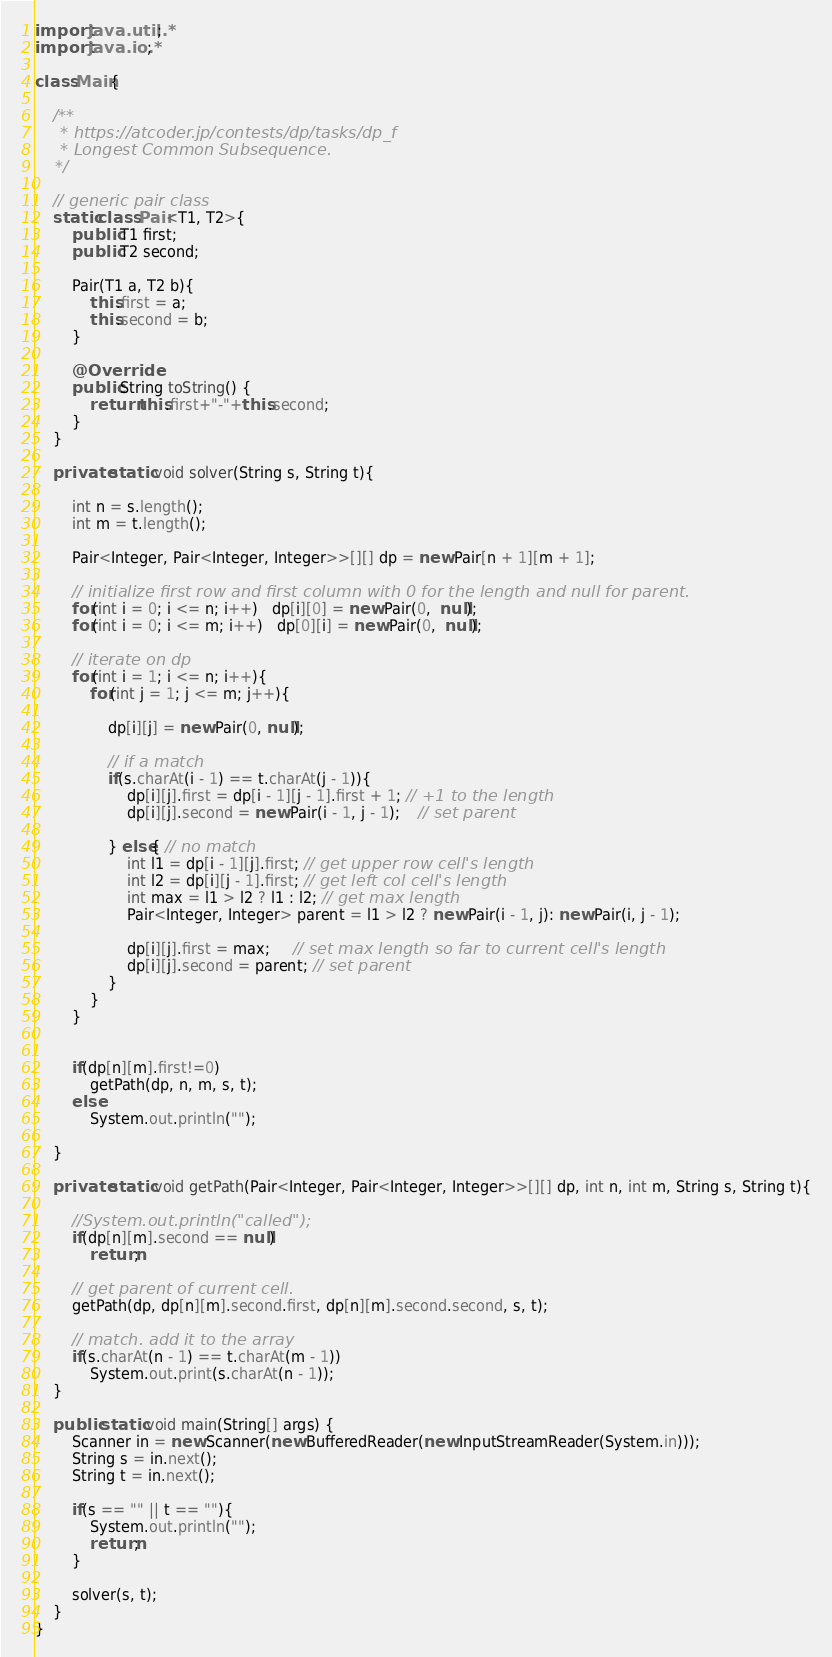<code> <loc_0><loc_0><loc_500><loc_500><_Java_>import java.util.*;
import java.io.*;

class Main{

    /**
     * https://atcoder.jp/contests/dp/tasks/dp_f
     * Longest Common Subsequence.
    */
    
    // generic pair class
    static class Pair<T1, T2>{
        public T1 first;
        public T2 second;

        Pair(T1 a, T2 b){
            this.first = a;
            this.second = b;
        }

        @Override
        public String toString() {
            return this.first+"-"+this.second;
        }
    }

    private static void solver(String s, String t){

        int n = s.length();
        int m = t.length();

        Pair<Integer, Pair<Integer, Integer>>[][] dp = new Pair[n + 1][m + 1];

        // initialize first row and first column with 0 for the length and null for parent.
        for(int i = 0; i <= n; i++)   dp[i][0] = new Pair(0,  null);
        for(int i = 0; i <= m; i++)   dp[0][i] = new Pair(0,  null);

        // iterate on dp
        for(int i = 1; i <= n; i++){
            for(int j = 1; j <= m; j++){

                dp[i][j] = new Pair(0, null);
                
                // if a match
                if(s.charAt(i - 1) == t.charAt(j - 1)){
                    dp[i][j].first = dp[i - 1][j - 1].first + 1; // +1 to the length
                    dp[i][j].second = new Pair(i - 1, j - 1);    // set parent

                } else{ // no match
                    int l1 = dp[i - 1][j].first; // get upper row cell's length
                    int l2 = dp[i][j - 1].first; // get left col cell's length
                    int max = l1 > l2 ? l1 : l2; // get max length
                    Pair<Integer, Integer> parent = l1 > l2 ? new Pair(i - 1, j): new Pair(i, j - 1);
                    
                    dp[i][j].first = max;     // set max length so far to current cell's length
                    dp[i][j].second = parent; // set parent 
                }
            }
        }


        if(dp[n][m].first!=0)
            getPath(dp, n, m, s, t);
        else
            System.out.println("");
        
    }

    private static void getPath(Pair<Integer, Pair<Integer, Integer>>[][] dp, int n, int m, String s, String t){

        //System.out.println("called");
        if(dp[n][m].second == null)
            return;

        // get parent of current cell.
        getPath(dp, dp[n][m].second.first, dp[n][m].second.second, s, t);

        // match. add it to the array
        if(s.charAt(n - 1) == t.charAt(m - 1))
            System.out.print(s.charAt(n - 1));
    }

    public static void main(String[] args) {
        Scanner in = new Scanner(new BufferedReader(new InputStreamReader(System.in)));
        String s = in.next();
        String t = in.next();

        if(s == "" || t == ""){
            System.out.println("");
            return;
        }

        solver(s, t);
    }
}</code> 